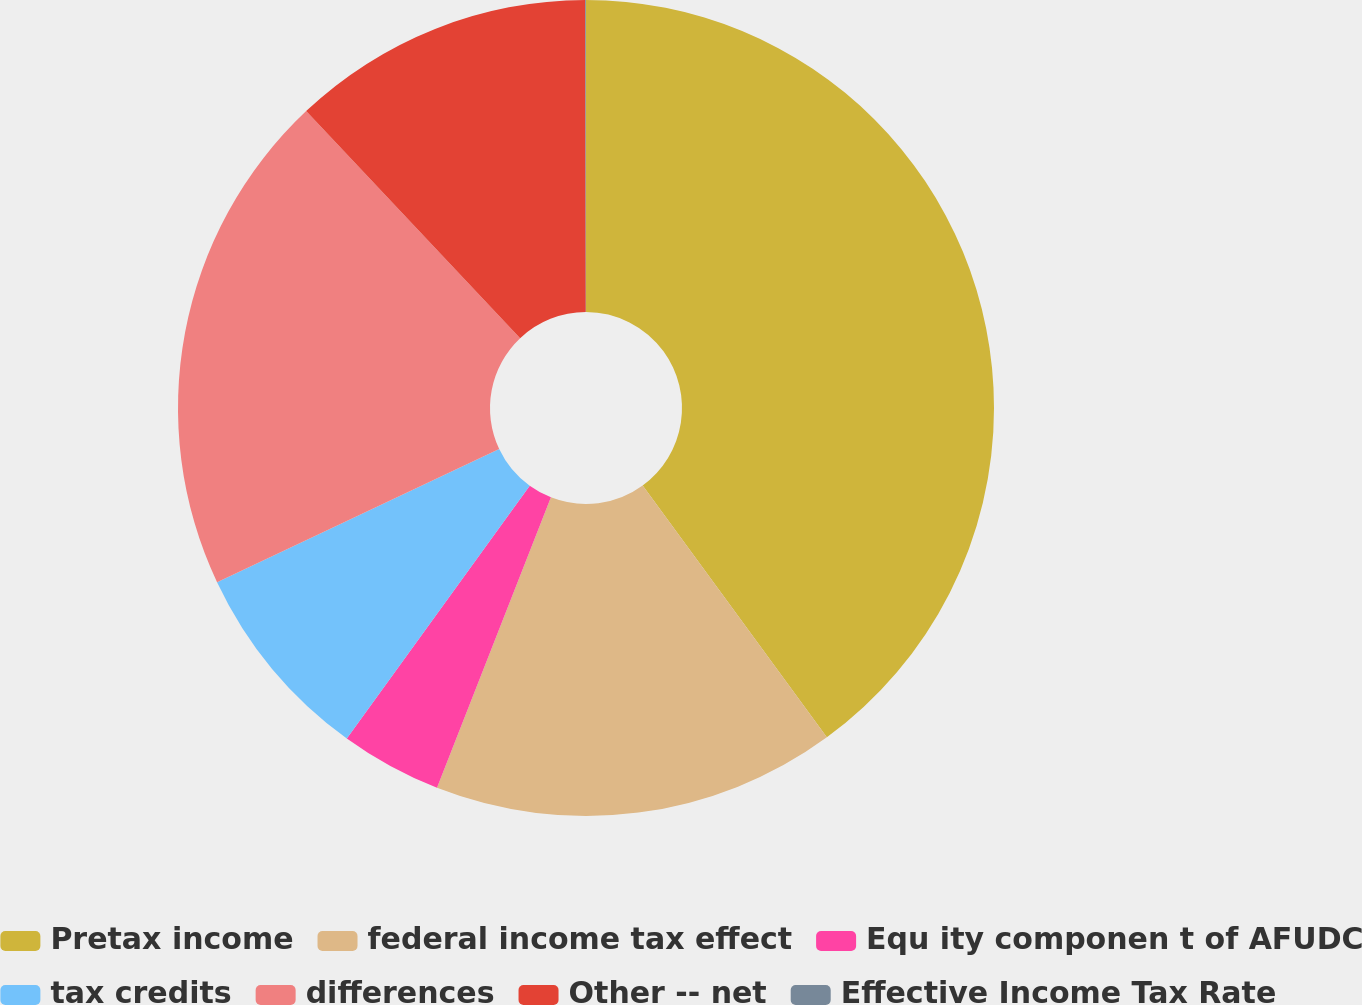Convert chart. <chart><loc_0><loc_0><loc_500><loc_500><pie_chart><fcel>Pretax income<fcel>federal income tax effect<fcel>Equ ity componen t of AFUDC<fcel>tax credits<fcel>differences<fcel>Other -- net<fcel>Effective Income Tax Rate<nl><fcel>39.95%<fcel>16.0%<fcel>4.02%<fcel>8.01%<fcel>19.99%<fcel>12.0%<fcel>0.03%<nl></chart> 